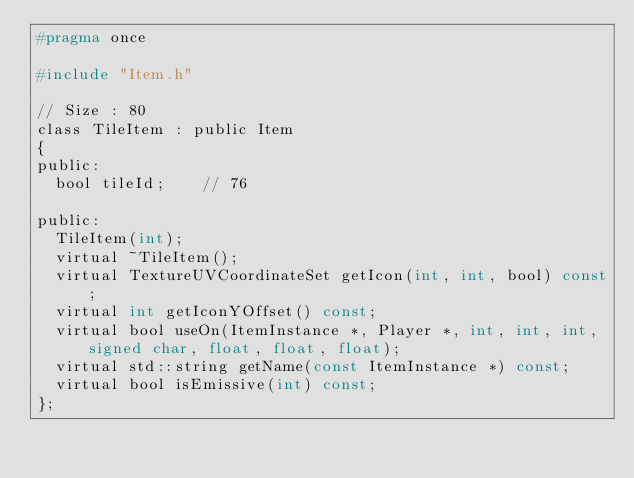Convert code to text. <code><loc_0><loc_0><loc_500><loc_500><_C_>#pragma once

#include "Item.h"

// Size : 80
class TileItem : public Item
{
public:
	bool tileId;		// 76

public:
	TileItem(int);
	virtual ~TileItem();
	virtual TextureUVCoordinateSet getIcon(int, int, bool) const;
	virtual int getIconYOffset() const;
	virtual bool useOn(ItemInstance *, Player *, int, int, int, signed char, float, float, float);
	virtual std::string getName(const ItemInstance *) const;
	virtual bool isEmissive(int) const;
};
</code> 